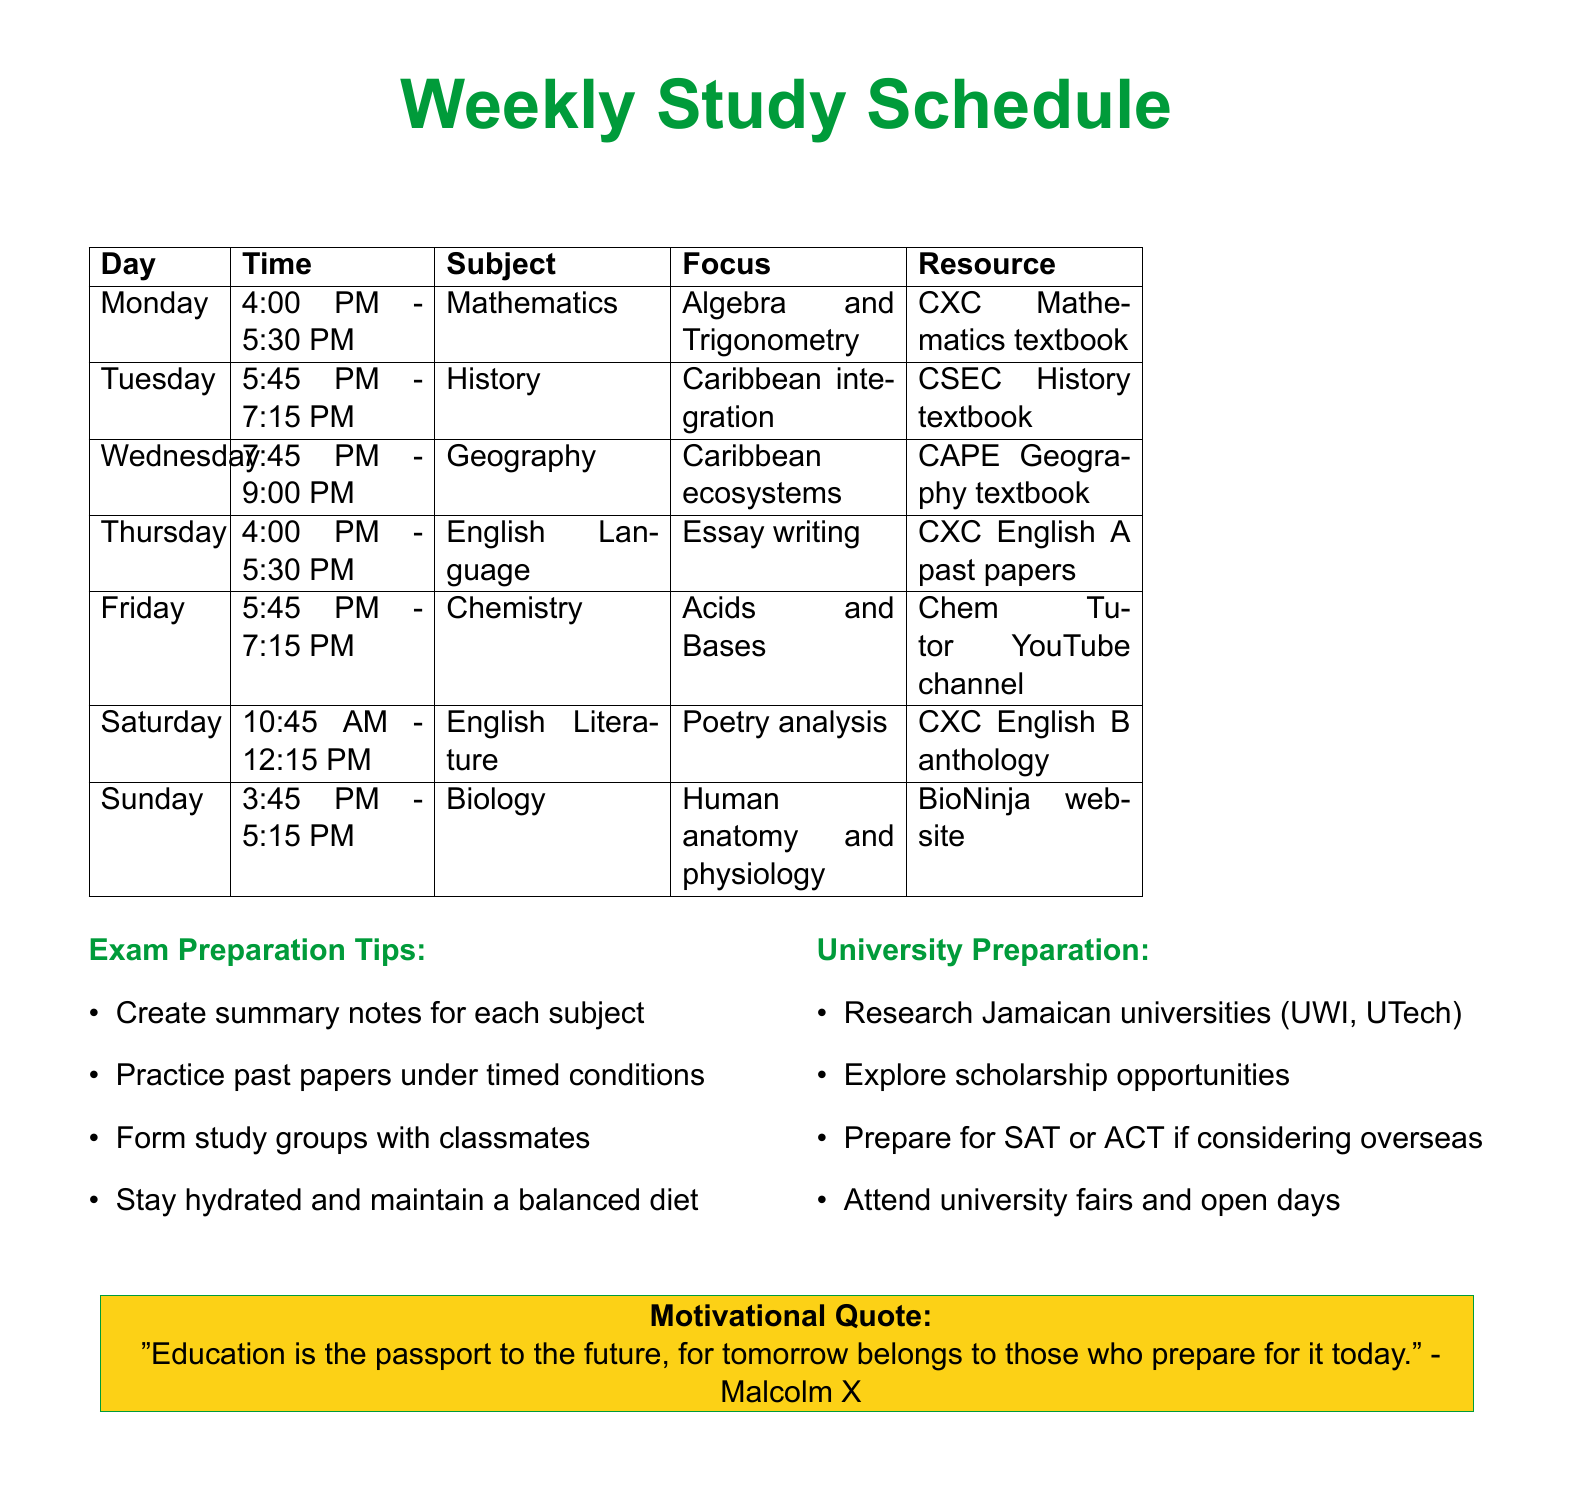What time is the first study session on Monday? The first study session on Monday starts at 4:00 PM.
Answer: 4:00 PM How many subjects are studied on Saturday? The document lists five subjects for Saturday.
Answer: Five What is the focus of the English Language session on Thursday? The focus of the English Language session on Thursday is essay writing.
Answer: Essay writing What resource is used for Biology Revision on Sunday? The resource used for Biology revision on Sunday is the BioNinja website.
Answer: BioNinja website Which subject is studied immediately after the dinner break on Tuesday? After the dinner break on Tuesday, the subject studied is Physics.
Answer: Physics What time does the weekly review take place on Sunday? The weekly review on Sunday takes place from 7:30 PM to 9:00 PM.
Answer: 7:30 PM - 9:00 PM Which two subjects have a focus on Chemistry this week? The subjects with a focus on Chemistry this week are Chemistry and Biology.
Answer: Chemistry, Biology What is one of the exam preparation tips mentioned in the document? One of the exam preparation tips is to create summary notes for each subject.
Answer: Create summary notes Which university is mentioned as a potential university to research? The University of the West Indies (UWI) is mentioned for research.
Answer: UWI 